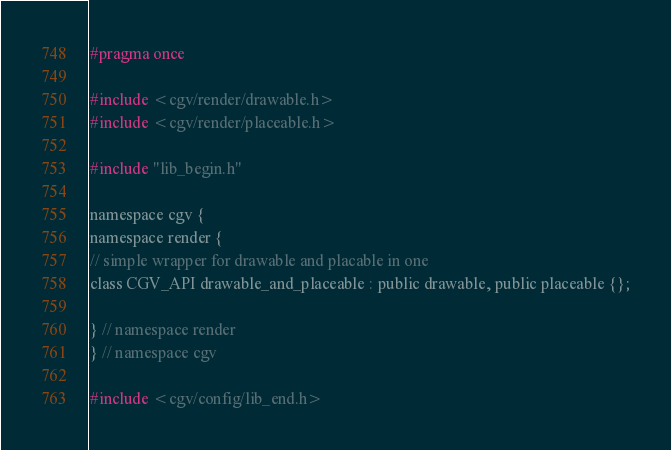<code> <loc_0><loc_0><loc_500><loc_500><_C_>#pragma once

#include <cgv/render/drawable.h>
#include <cgv/render/placeable.h>

#include "lib_begin.h"

namespace cgv {
namespace render {
// simple wrapper for drawable and placable in one
class CGV_API drawable_and_placeable : public drawable, public placeable {};

} // namespace render
} // namespace cgv

#include <cgv/config/lib_end.h></code> 